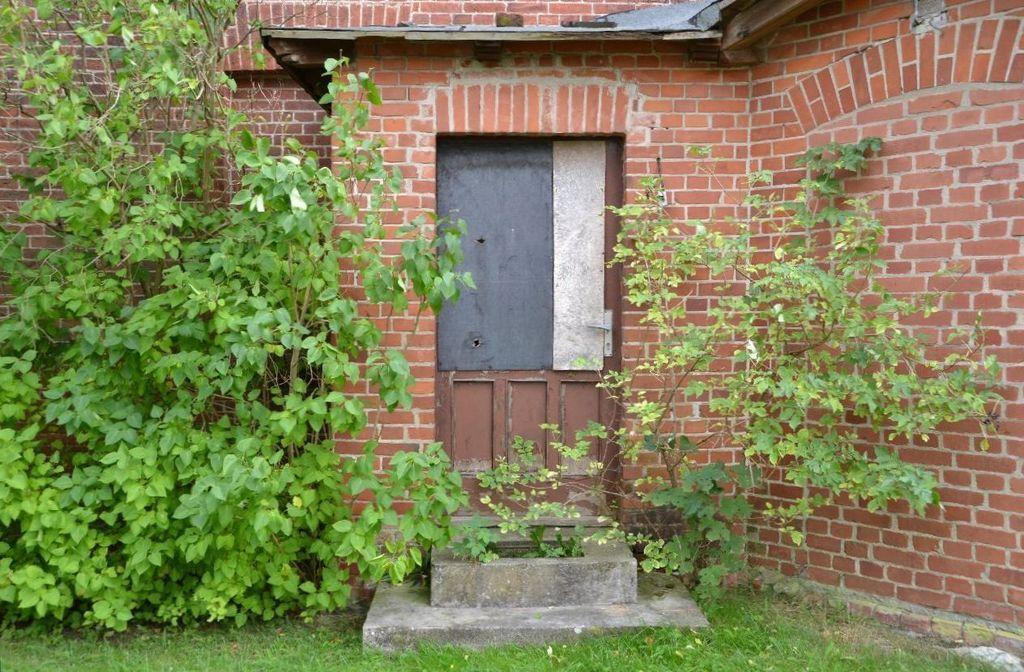What type of vegetation can be seen in the image? There are trees in the image. What type of structure is present in the image? There are brick walls in the image. Where are the brick walls located? The brick walls are located in the left and right corners. What is in the foreground of the image? There is a door in the foreground of the image. What is the ground made of in the image? There is green grass at the bottom of the image. What rule is being enforced by the trees in the image? There is no rule being enforced by the trees in the image; they are simply vegetation. Can you pull the door open in the image? The image is static, so you cannot interact with it or pull the door open. 